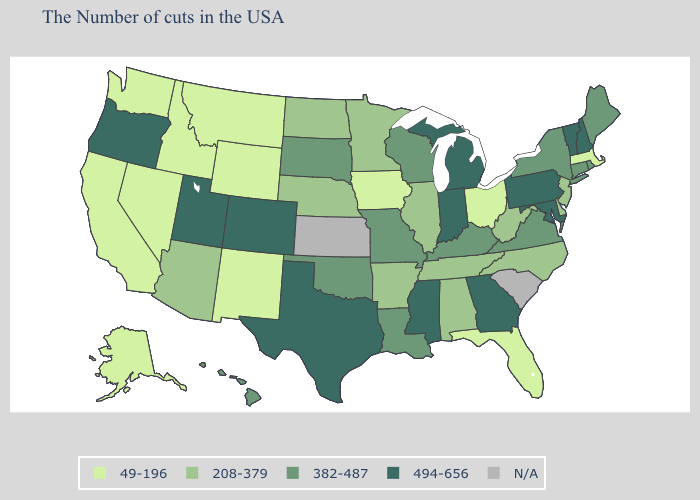What is the highest value in the South ?
Answer briefly. 494-656. What is the lowest value in the West?
Answer briefly. 49-196. Name the states that have a value in the range 208-379?
Answer briefly. New Jersey, Delaware, North Carolina, West Virginia, Alabama, Tennessee, Illinois, Arkansas, Minnesota, Nebraska, North Dakota, Arizona. Among the states that border South Carolina , does Georgia have the highest value?
Concise answer only. Yes. What is the value of Nevada?
Be succinct. 49-196. Among the states that border Alabama , does Florida have the lowest value?
Be succinct. Yes. What is the value of Arkansas?
Concise answer only. 208-379. What is the highest value in the USA?
Keep it brief. 494-656. Does Wyoming have the lowest value in the USA?
Keep it brief. Yes. Name the states that have a value in the range 49-196?
Answer briefly. Massachusetts, Ohio, Florida, Iowa, Wyoming, New Mexico, Montana, Idaho, Nevada, California, Washington, Alaska. How many symbols are there in the legend?
Write a very short answer. 5. Among the states that border Indiana , which have the highest value?
Write a very short answer. Michigan. Name the states that have a value in the range 49-196?
Answer briefly. Massachusetts, Ohio, Florida, Iowa, Wyoming, New Mexico, Montana, Idaho, Nevada, California, Washington, Alaska. 